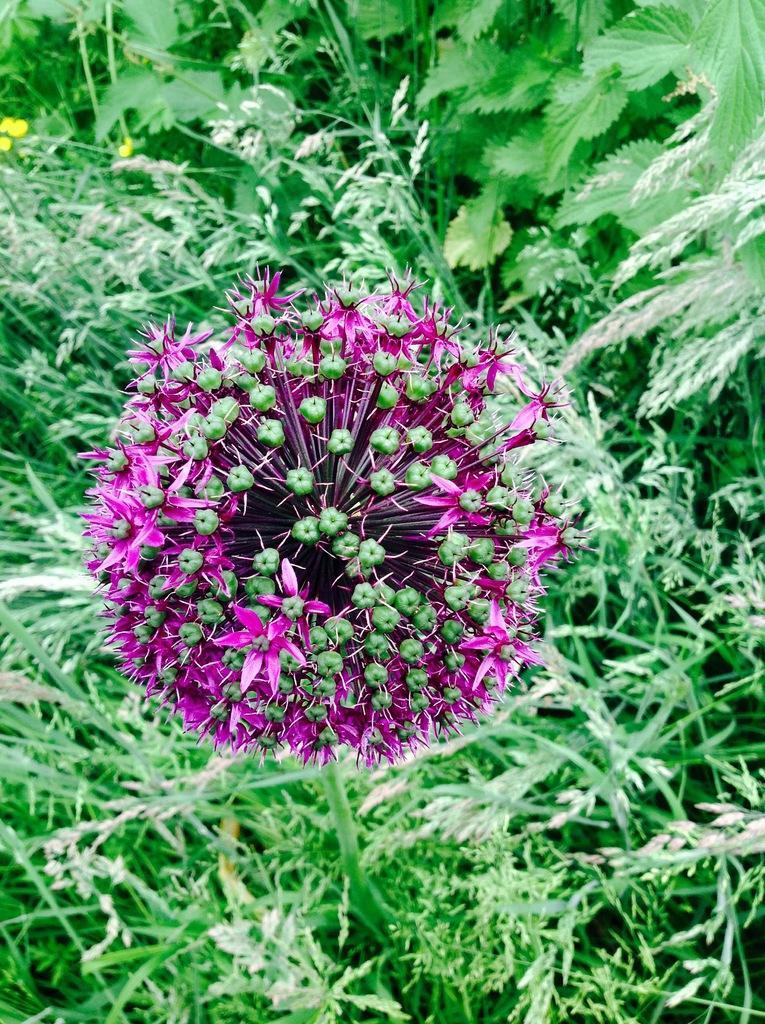In one or two sentences, can you explain what this image depicts? In this picture there are pink color flowers on the plant. At the back there are yellow color flowers on the plant. 